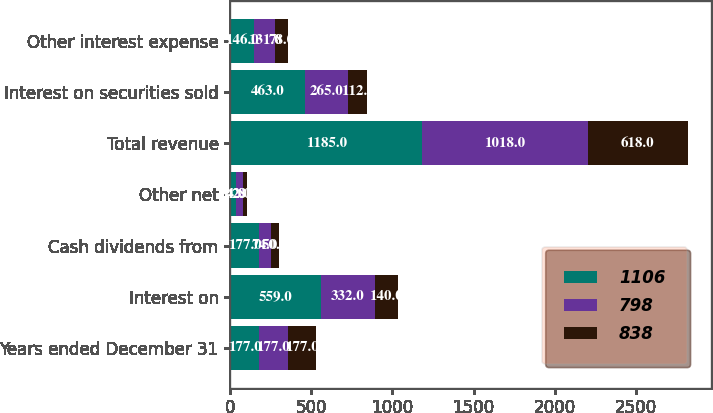Convert chart to OTSL. <chart><loc_0><loc_0><loc_500><loc_500><stacked_bar_chart><ecel><fcel>Years ended December 31<fcel>Interest on<fcel>Cash dividends from<fcel>Other net<fcel>Total revenue<fcel>Interest on securities sold<fcel>Other interest expense<nl><fcel>1106<fcel>177<fcel>559<fcel>177<fcel>34<fcel>1185<fcel>463<fcel>146<nl><fcel>798<fcel>177<fcel>332<fcel>74<fcel>42<fcel>1018<fcel>265<fcel>131<nl><fcel>838<fcel>177<fcel>140<fcel>50<fcel>28<fcel>618<fcel>112<fcel>78<nl></chart> 